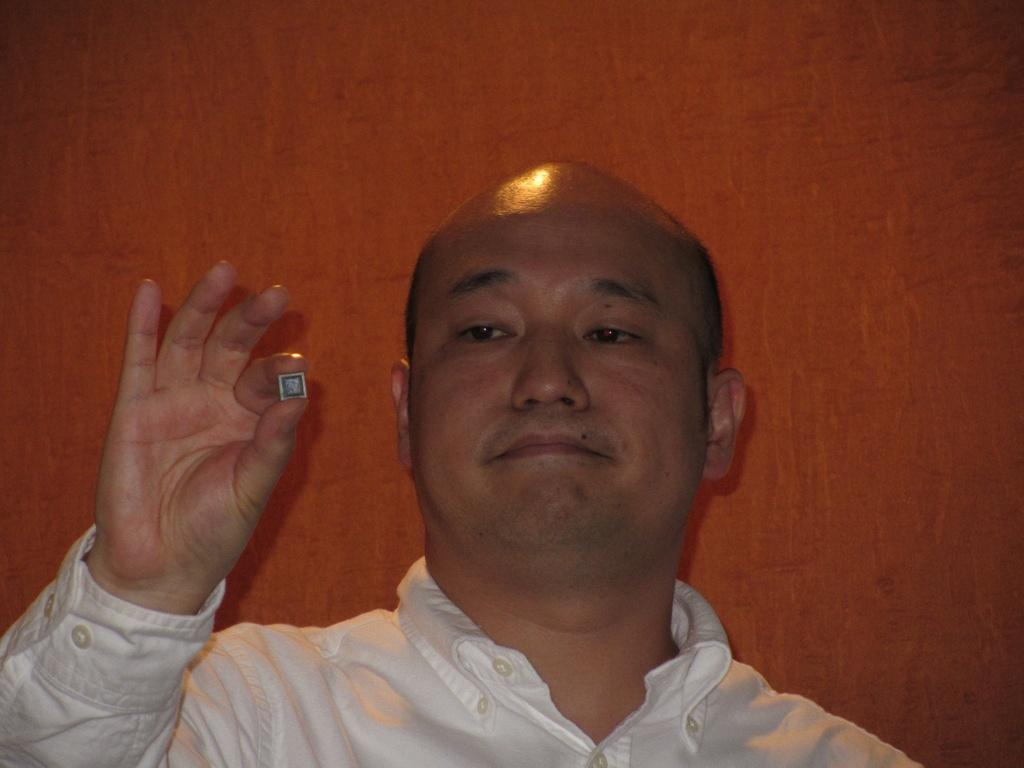What can be seen in the image? There is a person in the image. What is the person doing in the image? The person is holding an object. What can be seen in the background of the image? There is a wall in the background of the image. What type of wool is being used to make the beef in the image? There is no wool or beef present in the image. 